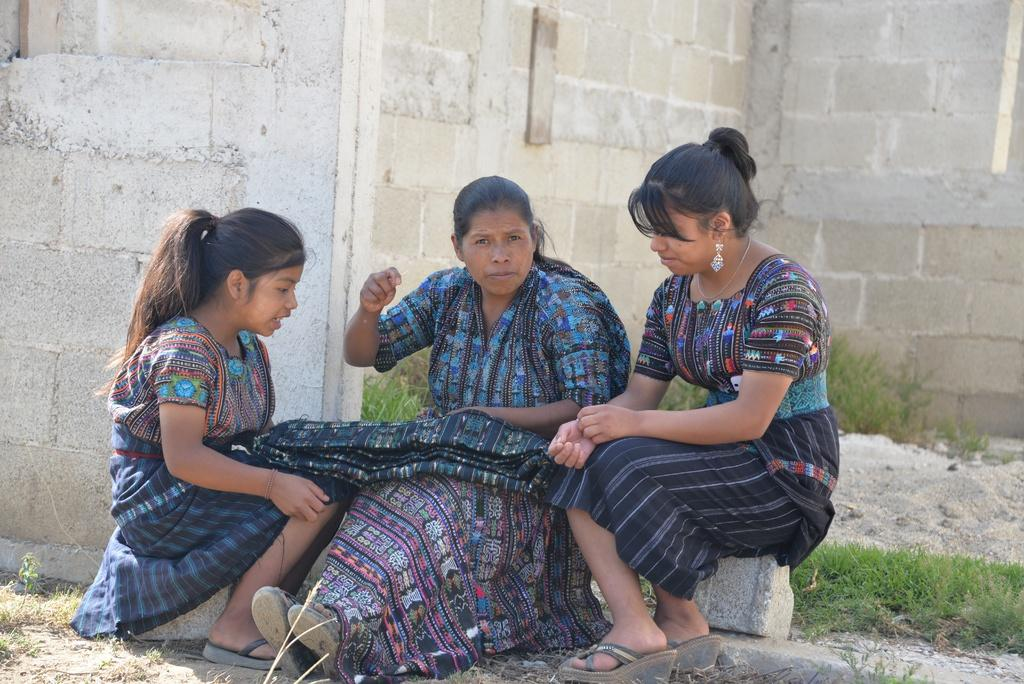How many people are in the image? There are three persons in the image. What are the persons wearing? The persons are wearing clothes. Where are the persons sitting? The persons are sitting in front of a wall. What type of vegetation can be seen in the image? There is grass in the bottom right of the image. What type of sticks are being used to turn the persons in the image? There are no sticks or turning motion present in the image; the persons are sitting still in front of a wall. 